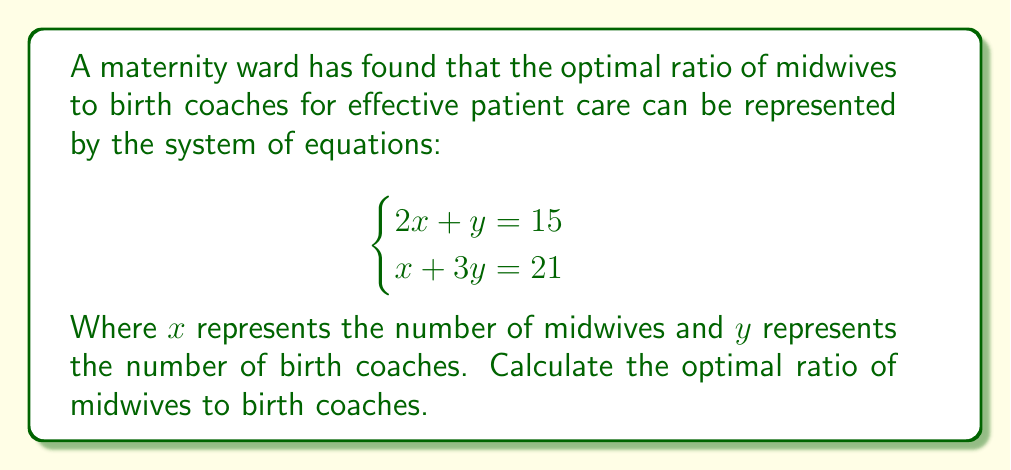Provide a solution to this math problem. To solve this system of equations and find the optimal ratio, we'll use the substitution method:

1) From the first equation, express $y$ in terms of $x$:
   $$2x + y = 15$$
   $$y = 15 - 2x$$

2) Substitute this expression for $y$ into the second equation:
   $$x + 3(15 - 2x) = 21$$

3) Simplify:
   $$x + 45 - 6x = 21$$
   $$45 - 5x = 21$$

4) Solve for $x$:
   $$-5x = -24$$
   $$x = \frac{24}{5} = 4.8$$

5) Substitute this value of $x$ back into the equation from step 1 to find $y$:
   $$y = 15 - 2(4.8) = 15 - 9.6 = 5.4$$

6) The optimal number of midwives is 4.8, and the optimal number of birth coaches is 5.4.

7) To express this as a ratio, we divide both numbers by their greatest common divisor:
   $$\frac{4.8}{5.4} = \frac{48}{54} = \frac{16}{18} = \frac{8}{9}$$

Therefore, the optimal ratio of midwives to birth coaches is 8:9.
Answer: 8:9 